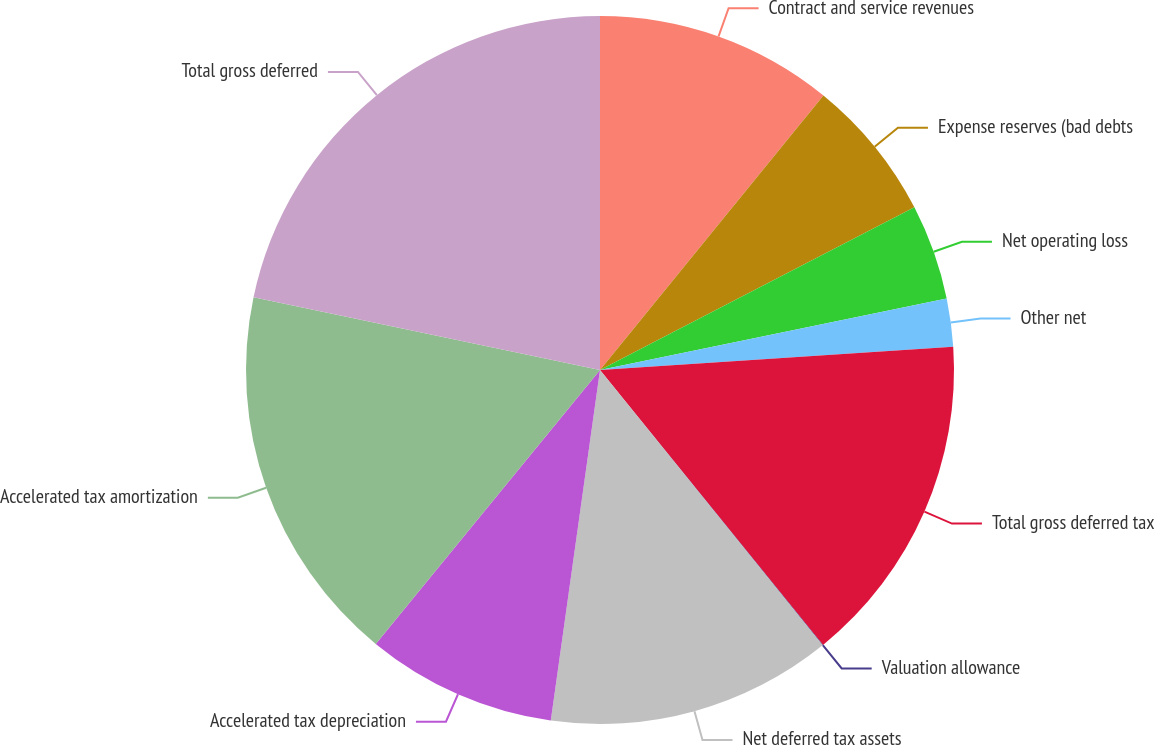<chart> <loc_0><loc_0><loc_500><loc_500><pie_chart><fcel>Contract and service revenues<fcel>Expense reserves (bad debts<fcel>Net operating loss<fcel>Other net<fcel>Total gross deferred tax<fcel>Valuation allowance<fcel>Net deferred tax assets<fcel>Accelerated tax depreciation<fcel>Accelerated tax amortization<fcel>Total gross deferred<nl><fcel>10.87%<fcel>6.53%<fcel>4.36%<fcel>2.19%<fcel>15.2%<fcel>0.03%<fcel>13.04%<fcel>8.7%<fcel>17.37%<fcel>21.71%<nl></chart> 